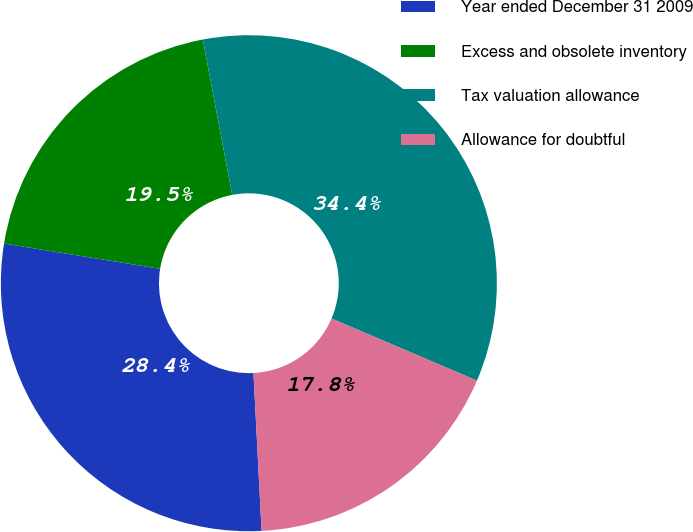<chart> <loc_0><loc_0><loc_500><loc_500><pie_chart><fcel>Year ended December 31 2009<fcel>Excess and obsolete inventory<fcel>Tax valuation allowance<fcel>Allowance for doubtful<nl><fcel>28.38%<fcel>19.47%<fcel>34.4%<fcel>17.76%<nl></chart> 